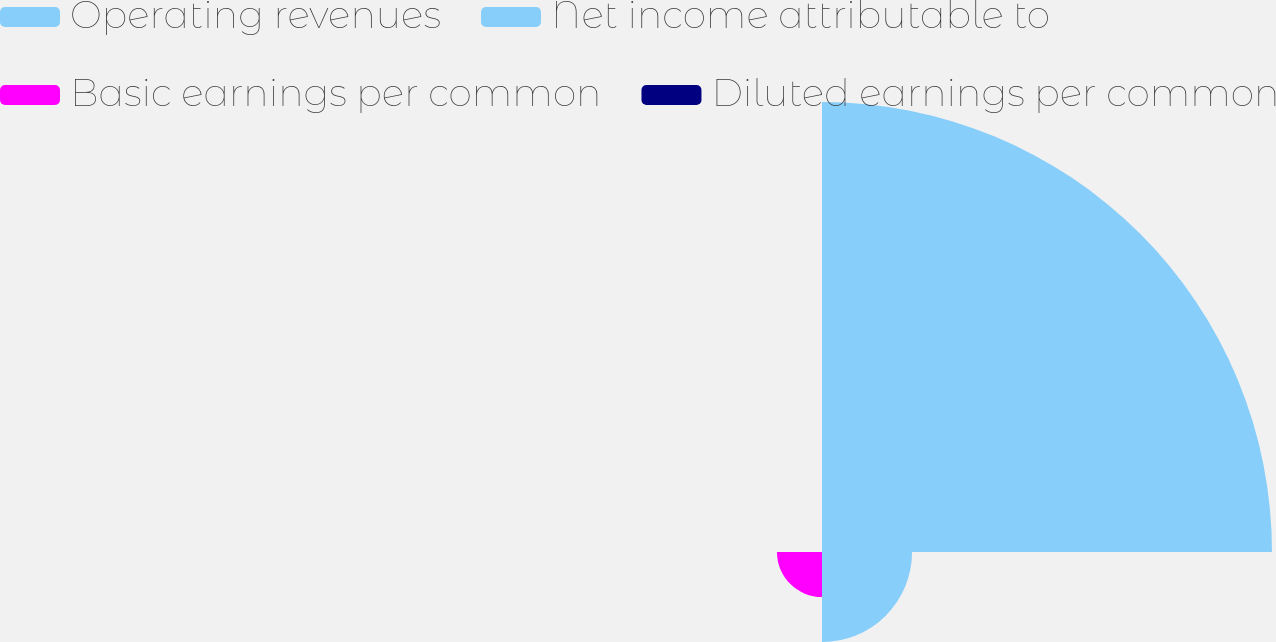Convert chart. <chart><loc_0><loc_0><loc_500><loc_500><pie_chart><fcel>Operating revenues<fcel>Net income attributable to<fcel>Basic earnings per common<fcel>Diluted earnings per common<nl><fcel>76.9%<fcel>15.39%<fcel>7.7%<fcel>0.01%<nl></chart> 